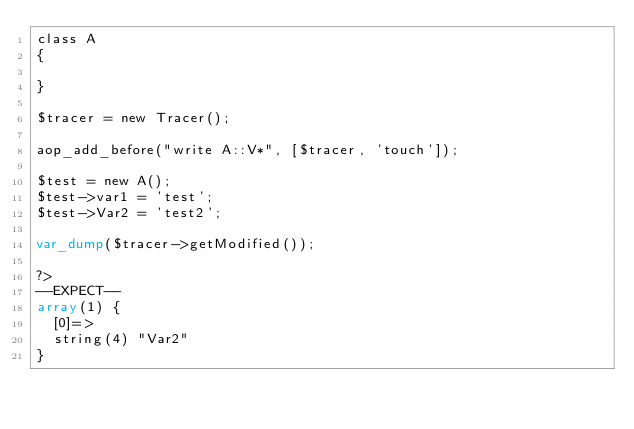Convert code to text. <code><loc_0><loc_0><loc_500><loc_500><_PHP_>class A
{

}

$tracer = new Tracer();

aop_add_before("write A::V*", [$tracer, 'touch']);

$test = new A();
$test->var1 = 'test';
$test->Var2 = 'test2';

var_dump($tracer->getModified());

?>
--EXPECT--
array(1) {
  [0]=>
  string(4) "Var2"
}
</code> 